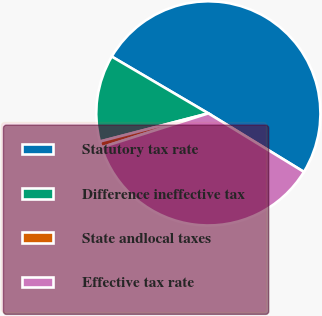<chart> <loc_0><loc_0><loc_500><loc_500><pie_chart><fcel>Statutory tax rate<fcel>Difference ineffective tax<fcel>State andlocal taxes<fcel>Effective tax rate<nl><fcel>50.29%<fcel>12.5%<fcel>0.86%<fcel>36.35%<nl></chart> 